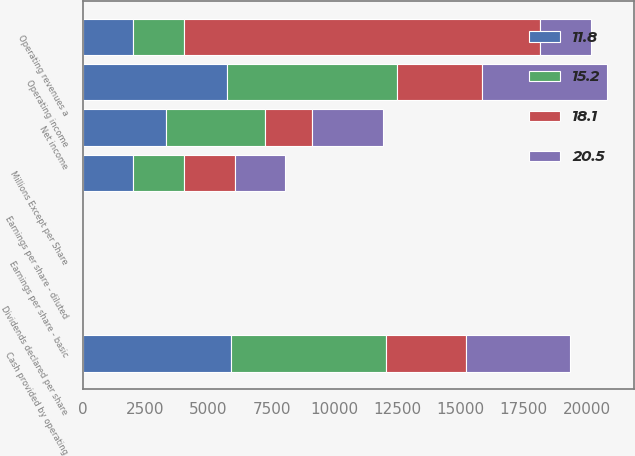Convert chart to OTSL. <chart><loc_0><loc_0><loc_500><loc_500><stacked_bar_chart><ecel><fcel>Millions Except per Share<fcel>Operating revenues a<fcel>Operating income<fcel>Net income<fcel>Earnings per share - basic<fcel>Earnings per share - diluted<fcel>Dividends declared per share<fcel>Cash provided by operating<nl><fcel>15.2<fcel>2012<fcel>2010<fcel>6745<fcel>3943<fcel>8.33<fcel>8.27<fcel>2.49<fcel>6161<nl><fcel>11.8<fcel>2011<fcel>2010<fcel>5724<fcel>3292<fcel>6.78<fcel>6.72<fcel>1.93<fcel>5873<nl><fcel>20.5<fcel>2010<fcel>2010<fcel>4981<fcel>2780<fcel>5.58<fcel>5.53<fcel>1.31<fcel>4105<nl><fcel>18.1<fcel>2009<fcel>14143<fcel>3379<fcel>1890<fcel>3.76<fcel>3.74<fcel>1.08<fcel>3204<nl></chart> 